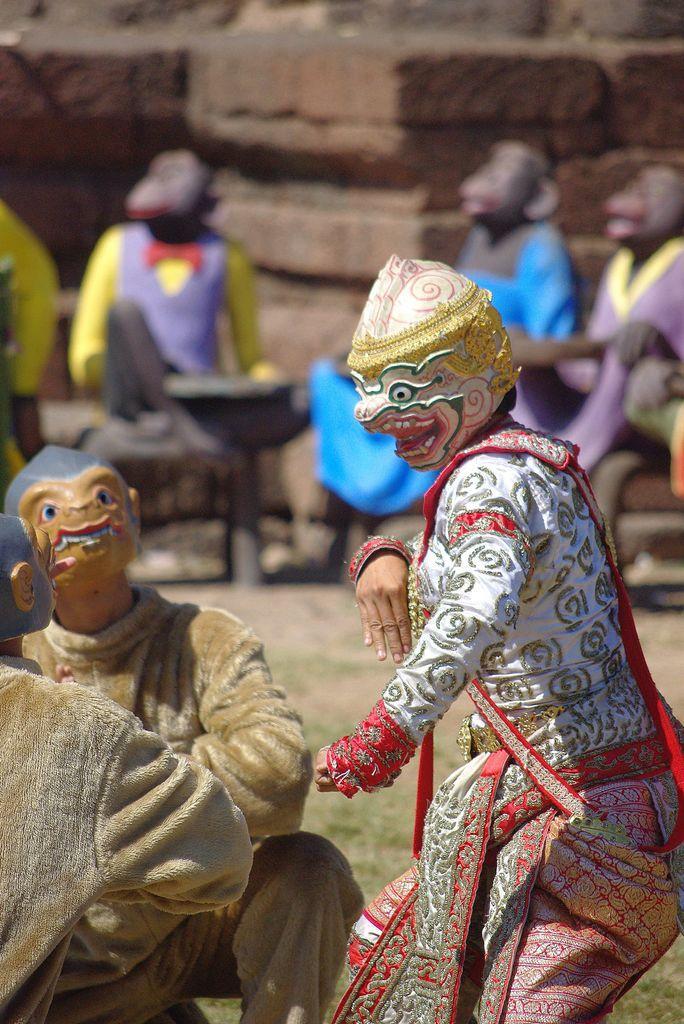Please provide a concise description of this image. In the foreground of this picture, there are three men performing an act by wearing masks and costumes. In the background, there are sculptures of monkeys, wall and the grass. 